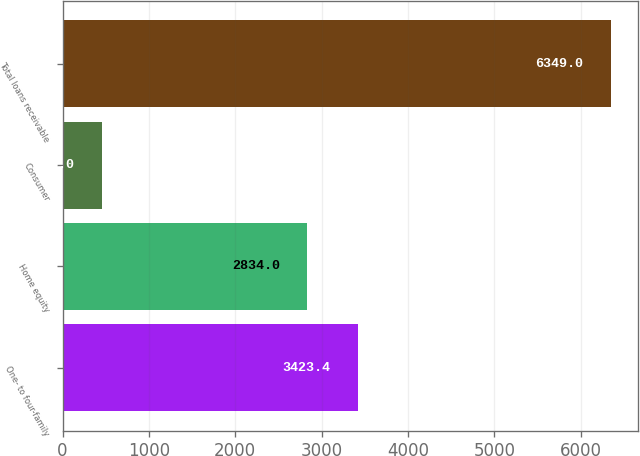Convert chart. <chart><loc_0><loc_0><loc_500><loc_500><bar_chart><fcel>One- to four-family<fcel>Home equity<fcel>Consumer<fcel>Total loans receivable<nl><fcel>3423.4<fcel>2834<fcel>455<fcel>6349<nl></chart> 